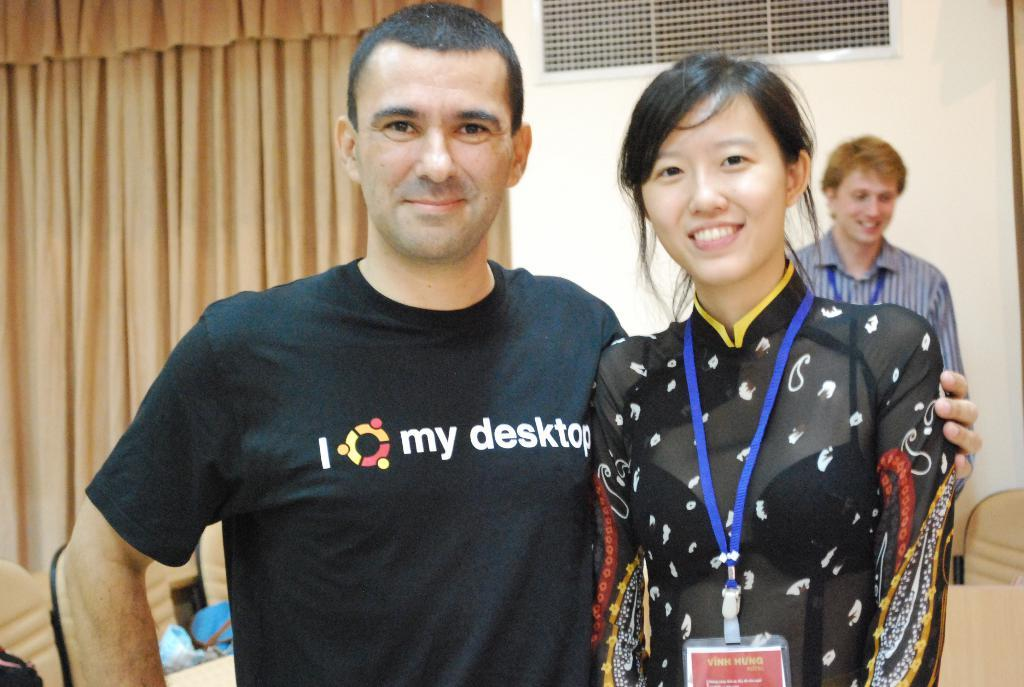<image>
Relay a brief, clear account of the picture shown. A man is posing with his arm around Vihn Hung. 